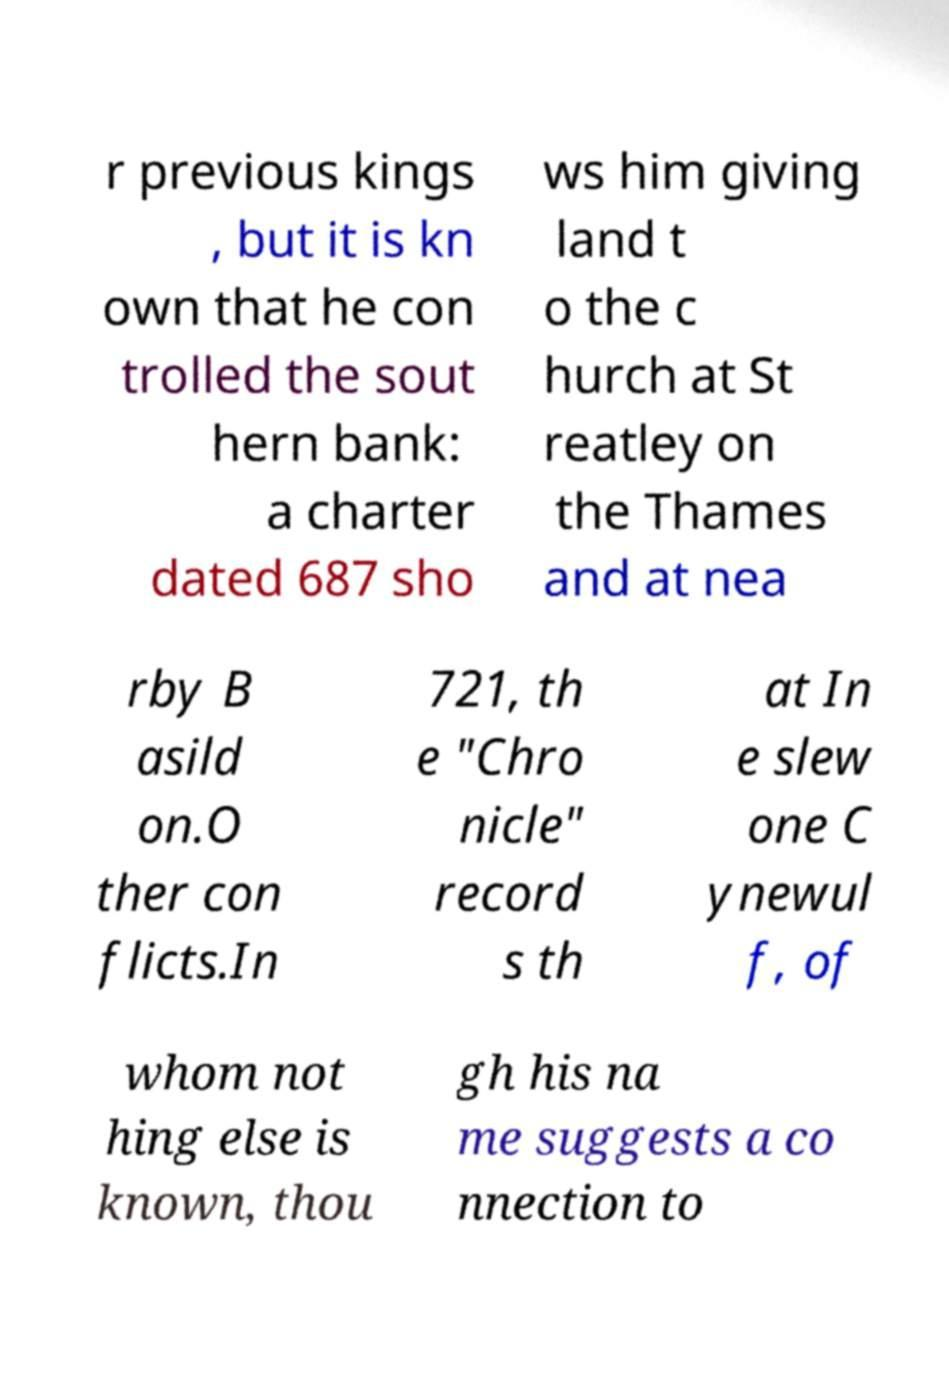Can you accurately transcribe the text from the provided image for me? r previous kings , but it is kn own that he con trolled the sout hern bank: a charter dated 687 sho ws him giving land t o the c hurch at St reatley on the Thames and at nea rby B asild on.O ther con flicts.In 721, th e "Chro nicle" record s th at In e slew one C ynewul f, of whom not hing else is known, thou gh his na me suggests a co nnection to 